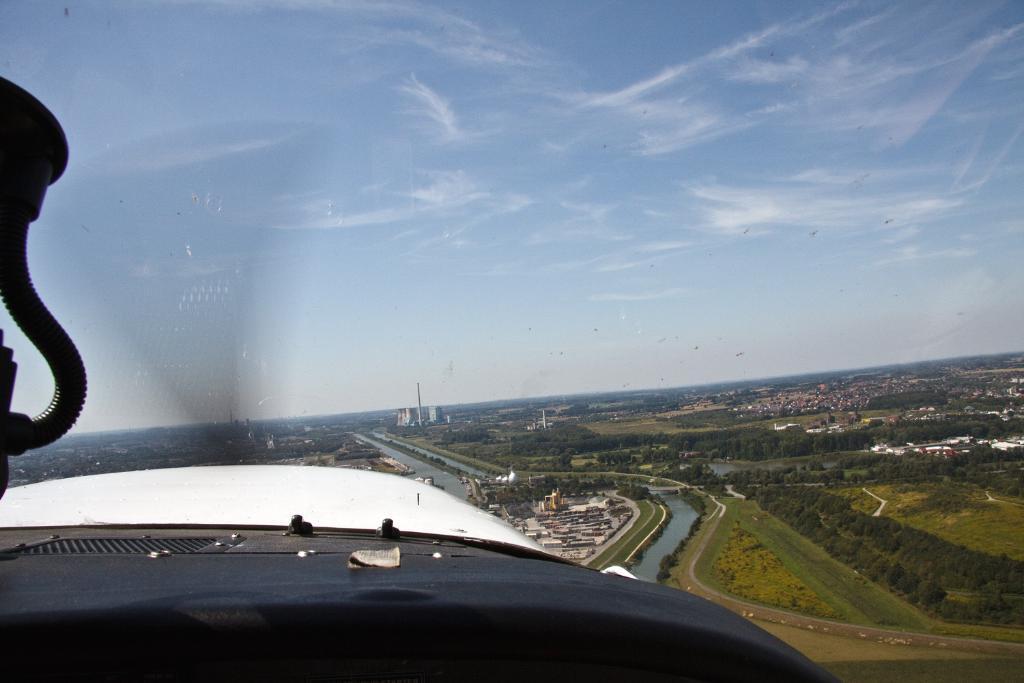Please provide a concise description of this image. This picture shows an aerial view of an area. We see blue cloudy sky and trees and buildings and we see water and few birds flying in the air. 